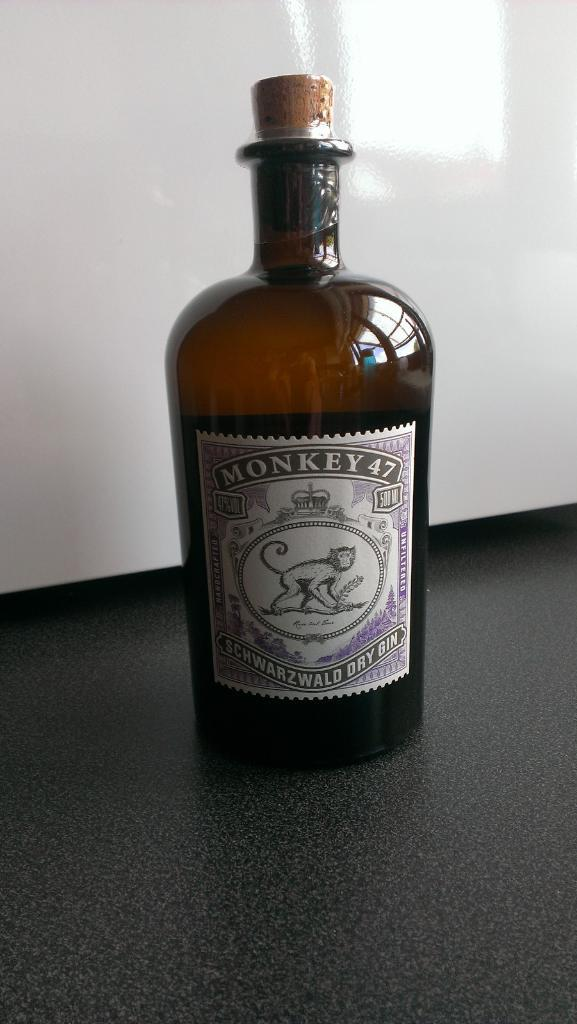Provide a one-sentence caption for the provided image. A large flask of Monkey 47 dry gin. 